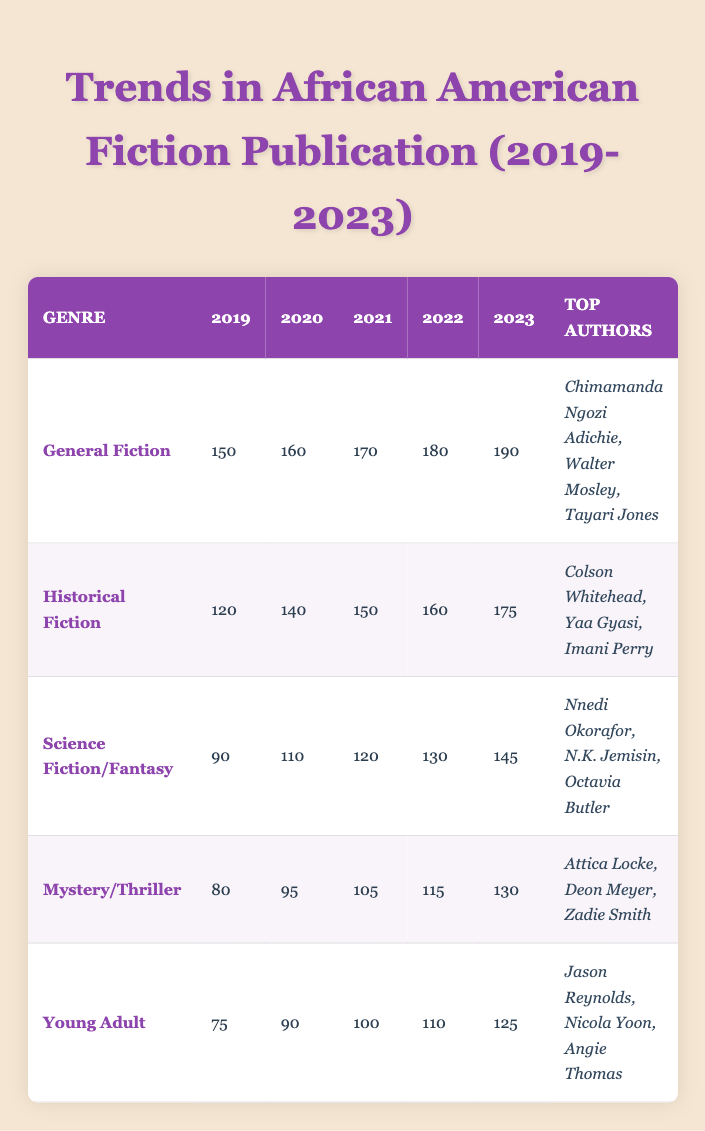What was the number of titles published in General Fiction in 2021? According to the table, the number of titles published in General Fiction in 2021 is explicitly listed as 170.
Answer: 170 Which genre had the highest number of titles published in 2023? Looking at the last column for the year 2023, General Fiction has the highest value with 190 titles published, more than any other genre listed.
Answer: General Fiction How many more titles were published in Historical Fiction in 2023 compared to 2019? In the table, the number of titles published in Historical Fiction in 2023 is 175, and in 2019 it was 120. The difference is calculated as 175 - 120 = 55.
Answer: 55 Is it true that Mystery/Thriller had more titles published in 2022 than in 2021? Checking the table, in 2022, 115 titles were published in Mystery/Thriller, while in 2021, 105 titles were published. Since 115 is greater than 105, the statement is true.
Answer: Yes What is the average number of titles published in Young Adult fiction from 2019 to 2023? First, we find the number of titles: 75 (2019) + 90 (2020) + 100 (2021) + 110 (2022) + 125 (2023) = 500. The average is calculated by dividing the total by the number of years (5), so 500/5 = 100.
Answer: 100 Which top author appears in both General Fiction and Historical Fiction? The table shows that Chimamanda Ngozi Adichie is listed under General Fiction, while Colson Whitehead is listed under Historical Fiction. No authors overlap in these two genres. Therefore, the answer is no authors appear in both genres.
Answer: None What was the growth in titles published in Science Fiction/Fantasy from 2019 to 2023? The number of titles published in Science Fiction/Fantasy in 2019 was 90, and in 2023 it was 145. The growth is calculated by subtracting the 2019 figure from the 2023 figure: 145 - 90 = 55.
Answer: 55 Did Young Adult fiction publish more titles in 2022 than Mystery/Thriller? Checking the data, Young Adult published 110 titles in 2022, while Mystery/Thriller published 115 titles. Since 110 is less than 115, the statement is false.
Answer: No 